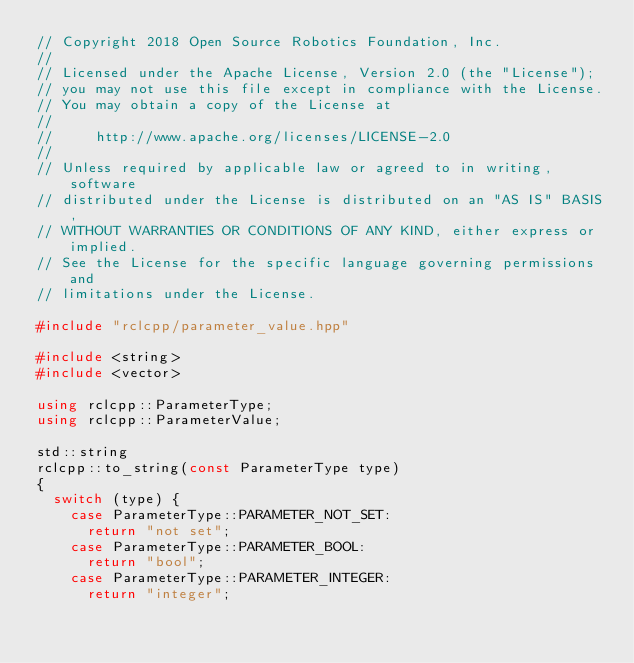Convert code to text. <code><loc_0><loc_0><loc_500><loc_500><_C++_>// Copyright 2018 Open Source Robotics Foundation, Inc.
//
// Licensed under the Apache License, Version 2.0 (the "License");
// you may not use this file except in compliance with the License.
// You may obtain a copy of the License at
//
//     http://www.apache.org/licenses/LICENSE-2.0
//
// Unless required by applicable law or agreed to in writing, software
// distributed under the License is distributed on an "AS IS" BASIS,
// WITHOUT WARRANTIES OR CONDITIONS OF ANY KIND, either express or implied.
// See the License for the specific language governing permissions and
// limitations under the License.

#include "rclcpp/parameter_value.hpp"

#include <string>
#include <vector>

using rclcpp::ParameterType;
using rclcpp::ParameterValue;

std::string
rclcpp::to_string(const ParameterType type)
{
  switch (type) {
    case ParameterType::PARAMETER_NOT_SET:
      return "not set";
    case ParameterType::PARAMETER_BOOL:
      return "bool";
    case ParameterType::PARAMETER_INTEGER:
      return "integer";</code> 